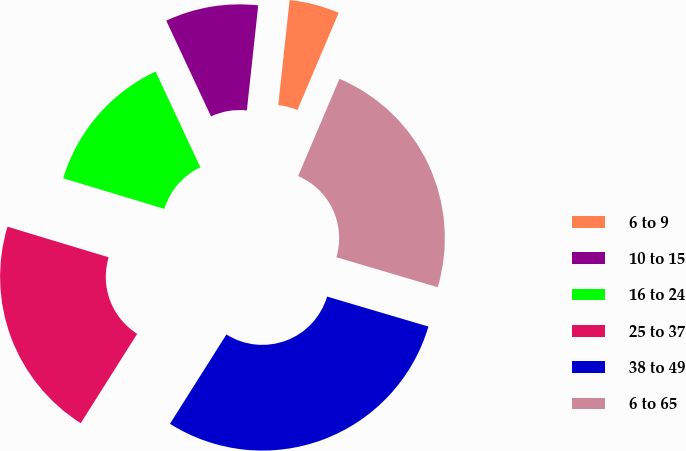<chart> <loc_0><loc_0><loc_500><loc_500><pie_chart><fcel>6 to 9<fcel>10 to 15<fcel>16 to 24<fcel>25 to 37<fcel>38 to 49<fcel>6 to 65<nl><fcel>4.68%<fcel>8.68%<fcel>13.36%<fcel>20.71%<fcel>29.39%<fcel>23.18%<nl></chart> 